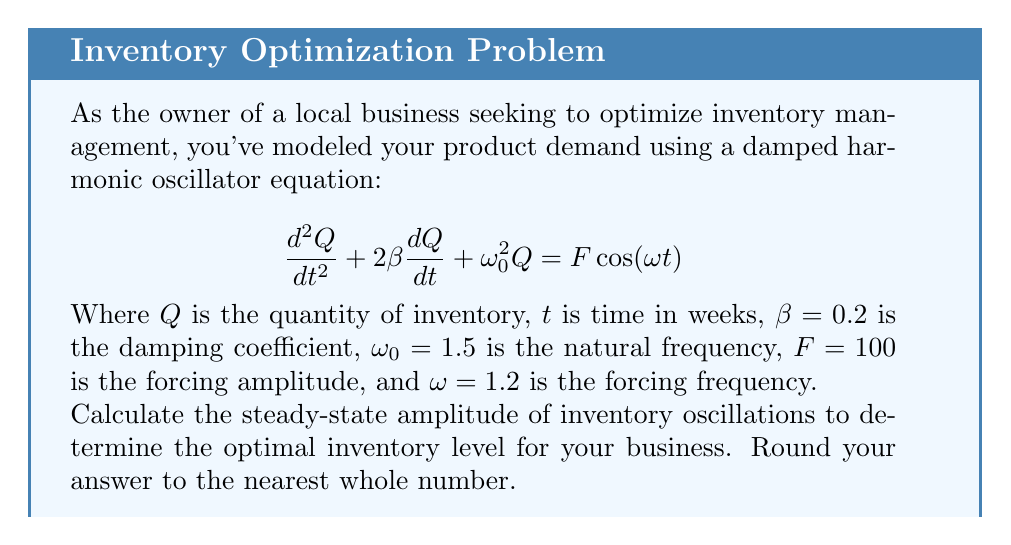Solve this math problem. To solve this problem, we'll follow these steps:

1) The steady-state solution for a damped, forced harmonic oscillator is of the form:

   $$Q(t) = A\cos(\omega t - \phi)$$

   where $A$ is the amplitude we're looking for.

2) The amplitude $A$ is given by the formula:

   $$A = \frac{F}{\sqrt{(\omega_0^2 - \omega^2)^2 + 4\beta^2\omega^2}}$$

3) Let's substitute the given values:
   $F = 100$
   $\omega_0 = 1.5$
   $\omega = 1.2$
   $\beta = 0.2$

4) Now, let's calculate step by step:

   $$A = \frac{100}{\sqrt{(1.5^2 - 1.2^2)^2 + 4(0.2^2)(1.2^2)}}$$

5) Simplify inside the square root:
   
   $$A = \frac{100}{\sqrt{(2.25 - 1.44)^2 + 4(0.04)(1.44)}}$$
   
   $$A = \frac{100}{\sqrt{0.81^2 + 0.2304}}$$

6) Calculate:
   
   $$A = \frac{100}{\sqrt{0.6561 + 0.2304}} = \frac{100}{\sqrt{0.8865}} = \frac{100}{0.9416} = 106.2$$

7) Rounding to the nearest whole number:

   $A \approx 106$

This means the inventory will oscillate with an amplitude of approximately 106 units around the equilibrium point.
Answer: 106 units 